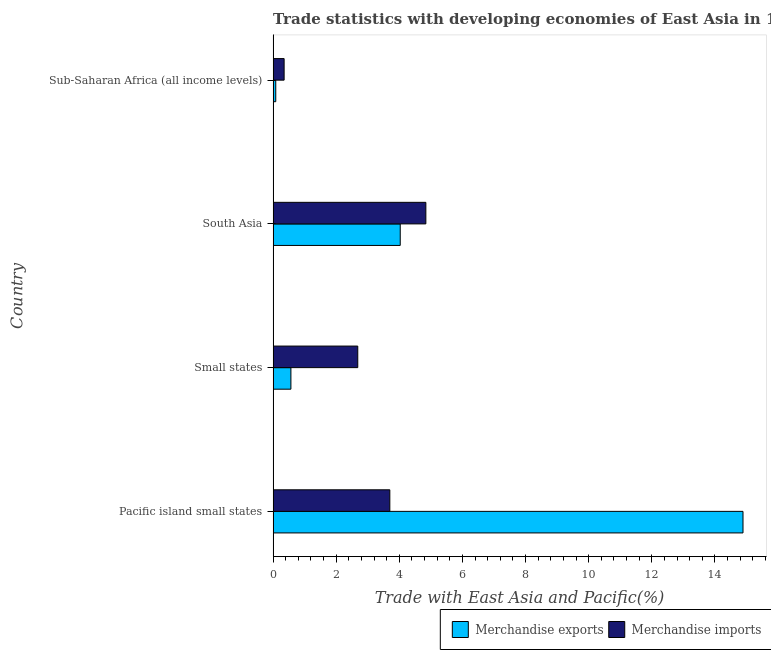How many groups of bars are there?
Ensure brevity in your answer.  4. Are the number of bars per tick equal to the number of legend labels?
Offer a very short reply. Yes. How many bars are there on the 3rd tick from the top?
Your answer should be very brief. 2. What is the label of the 3rd group of bars from the top?
Provide a succinct answer. Small states. What is the merchandise imports in Sub-Saharan Africa (all income levels)?
Offer a terse response. 0.35. Across all countries, what is the maximum merchandise exports?
Offer a very short reply. 14.89. Across all countries, what is the minimum merchandise imports?
Keep it short and to the point. 0.35. In which country was the merchandise imports maximum?
Provide a short and direct response. South Asia. In which country was the merchandise imports minimum?
Your answer should be very brief. Sub-Saharan Africa (all income levels). What is the total merchandise exports in the graph?
Provide a succinct answer. 19.56. What is the difference between the merchandise imports in Pacific island small states and that in Sub-Saharan Africa (all income levels)?
Your answer should be compact. 3.35. What is the difference between the merchandise imports in Pacific island small states and the merchandise exports in Sub-Saharan Africa (all income levels)?
Keep it short and to the point. 3.61. What is the average merchandise exports per country?
Give a very brief answer. 4.89. What is the difference between the merchandise exports and merchandise imports in Pacific island small states?
Offer a terse response. 11.19. In how many countries, is the merchandise exports greater than 2 %?
Give a very brief answer. 2. What is the ratio of the merchandise imports in Small states to that in Sub-Saharan Africa (all income levels)?
Provide a succinct answer. 7.69. Is the merchandise imports in Small states less than that in South Asia?
Your response must be concise. Yes. What is the difference between the highest and the second highest merchandise imports?
Offer a terse response. 1.14. What is the difference between the highest and the lowest merchandise imports?
Make the answer very short. 4.49. What does the 2nd bar from the bottom in Small states represents?
Your answer should be very brief. Merchandise imports. How many bars are there?
Your answer should be very brief. 8. How many countries are there in the graph?
Your answer should be very brief. 4. Are the values on the major ticks of X-axis written in scientific E-notation?
Make the answer very short. No. Where does the legend appear in the graph?
Your answer should be very brief. Bottom right. How many legend labels are there?
Give a very brief answer. 2. How are the legend labels stacked?
Provide a succinct answer. Horizontal. What is the title of the graph?
Your answer should be very brief. Trade statistics with developing economies of East Asia in 1982. What is the label or title of the X-axis?
Provide a succinct answer. Trade with East Asia and Pacific(%). What is the Trade with East Asia and Pacific(%) in Merchandise exports in Pacific island small states?
Provide a short and direct response. 14.89. What is the Trade with East Asia and Pacific(%) in Merchandise imports in Pacific island small states?
Keep it short and to the point. 3.7. What is the Trade with East Asia and Pacific(%) of Merchandise exports in Small states?
Offer a very short reply. 0.56. What is the Trade with East Asia and Pacific(%) in Merchandise imports in Small states?
Make the answer very short. 2.68. What is the Trade with East Asia and Pacific(%) in Merchandise exports in South Asia?
Make the answer very short. 4.03. What is the Trade with East Asia and Pacific(%) of Merchandise imports in South Asia?
Your answer should be compact. 4.84. What is the Trade with East Asia and Pacific(%) of Merchandise exports in Sub-Saharan Africa (all income levels)?
Offer a terse response. 0.08. What is the Trade with East Asia and Pacific(%) in Merchandise imports in Sub-Saharan Africa (all income levels)?
Provide a short and direct response. 0.35. Across all countries, what is the maximum Trade with East Asia and Pacific(%) in Merchandise exports?
Provide a succinct answer. 14.89. Across all countries, what is the maximum Trade with East Asia and Pacific(%) in Merchandise imports?
Your answer should be very brief. 4.84. Across all countries, what is the minimum Trade with East Asia and Pacific(%) in Merchandise exports?
Your response must be concise. 0.08. Across all countries, what is the minimum Trade with East Asia and Pacific(%) of Merchandise imports?
Offer a terse response. 0.35. What is the total Trade with East Asia and Pacific(%) of Merchandise exports in the graph?
Keep it short and to the point. 19.56. What is the total Trade with East Asia and Pacific(%) of Merchandise imports in the graph?
Your answer should be compact. 11.57. What is the difference between the Trade with East Asia and Pacific(%) in Merchandise exports in Pacific island small states and that in Small states?
Your answer should be very brief. 14.33. What is the difference between the Trade with East Asia and Pacific(%) of Merchandise imports in Pacific island small states and that in Small states?
Your answer should be very brief. 1.02. What is the difference between the Trade with East Asia and Pacific(%) of Merchandise exports in Pacific island small states and that in South Asia?
Offer a very short reply. 10.86. What is the difference between the Trade with East Asia and Pacific(%) of Merchandise imports in Pacific island small states and that in South Asia?
Make the answer very short. -1.14. What is the difference between the Trade with East Asia and Pacific(%) of Merchandise exports in Pacific island small states and that in Sub-Saharan Africa (all income levels)?
Your answer should be compact. 14.8. What is the difference between the Trade with East Asia and Pacific(%) of Merchandise imports in Pacific island small states and that in Sub-Saharan Africa (all income levels)?
Provide a short and direct response. 3.35. What is the difference between the Trade with East Asia and Pacific(%) of Merchandise exports in Small states and that in South Asia?
Your answer should be very brief. -3.46. What is the difference between the Trade with East Asia and Pacific(%) in Merchandise imports in Small states and that in South Asia?
Provide a succinct answer. -2.16. What is the difference between the Trade with East Asia and Pacific(%) in Merchandise exports in Small states and that in Sub-Saharan Africa (all income levels)?
Make the answer very short. 0.48. What is the difference between the Trade with East Asia and Pacific(%) in Merchandise imports in Small states and that in Sub-Saharan Africa (all income levels)?
Give a very brief answer. 2.33. What is the difference between the Trade with East Asia and Pacific(%) in Merchandise exports in South Asia and that in Sub-Saharan Africa (all income levels)?
Make the answer very short. 3.94. What is the difference between the Trade with East Asia and Pacific(%) in Merchandise imports in South Asia and that in Sub-Saharan Africa (all income levels)?
Offer a terse response. 4.49. What is the difference between the Trade with East Asia and Pacific(%) in Merchandise exports in Pacific island small states and the Trade with East Asia and Pacific(%) in Merchandise imports in Small states?
Make the answer very short. 12.21. What is the difference between the Trade with East Asia and Pacific(%) of Merchandise exports in Pacific island small states and the Trade with East Asia and Pacific(%) of Merchandise imports in South Asia?
Give a very brief answer. 10.05. What is the difference between the Trade with East Asia and Pacific(%) of Merchandise exports in Pacific island small states and the Trade with East Asia and Pacific(%) of Merchandise imports in Sub-Saharan Africa (all income levels)?
Give a very brief answer. 14.54. What is the difference between the Trade with East Asia and Pacific(%) of Merchandise exports in Small states and the Trade with East Asia and Pacific(%) of Merchandise imports in South Asia?
Make the answer very short. -4.28. What is the difference between the Trade with East Asia and Pacific(%) of Merchandise exports in Small states and the Trade with East Asia and Pacific(%) of Merchandise imports in Sub-Saharan Africa (all income levels)?
Give a very brief answer. 0.22. What is the difference between the Trade with East Asia and Pacific(%) in Merchandise exports in South Asia and the Trade with East Asia and Pacific(%) in Merchandise imports in Sub-Saharan Africa (all income levels)?
Make the answer very short. 3.68. What is the average Trade with East Asia and Pacific(%) in Merchandise exports per country?
Give a very brief answer. 4.89. What is the average Trade with East Asia and Pacific(%) of Merchandise imports per country?
Provide a short and direct response. 2.89. What is the difference between the Trade with East Asia and Pacific(%) of Merchandise exports and Trade with East Asia and Pacific(%) of Merchandise imports in Pacific island small states?
Your answer should be very brief. 11.19. What is the difference between the Trade with East Asia and Pacific(%) in Merchandise exports and Trade with East Asia and Pacific(%) in Merchandise imports in Small states?
Offer a terse response. -2.12. What is the difference between the Trade with East Asia and Pacific(%) in Merchandise exports and Trade with East Asia and Pacific(%) in Merchandise imports in South Asia?
Your response must be concise. -0.81. What is the difference between the Trade with East Asia and Pacific(%) of Merchandise exports and Trade with East Asia and Pacific(%) of Merchandise imports in Sub-Saharan Africa (all income levels)?
Your response must be concise. -0.26. What is the ratio of the Trade with East Asia and Pacific(%) in Merchandise exports in Pacific island small states to that in Small states?
Keep it short and to the point. 26.41. What is the ratio of the Trade with East Asia and Pacific(%) of Merchandise imports in Pacific island small states to that in Small states?
Provide a short and direct response. 1.38. What is the ratio of the Trade with East Asia and Pacific(%) of Merchandise exports in Pacific island small states to that in South Asia?
Your answer should be compact. 3.7. What is the ratio of the Trade with East Asia and Pacific(%) in Merchandise imports in Pacific island small states to that in South Asia?
Provide a succinct answer. 0.76. What is the ratio of the Trade with East Asia and Pacific(%) of Merchandise exports in Pacific island small states to that in Sub-Saharan Africa (all income levels)?
Keep it short and to the point. 177.59. What is the ratio of the Trade with East Asia and Pacific(%) of Merchandise imports in Pacific island small states to that in Sub-Saharan Africa (all income levels)?
Your response must be concise. 10.61. What is the ratio of the Trade with East Asia and Pacific(%) of Merchandise exports in Small states to that in South Asia?
Keep it short and to the point. 0.14. What is the ratio of the Trade with East Asia and Pacific(%) in Merchandise imports in Small states to that in South Asia?
Offer a very short reply. 0.55. What is the ratio of the Trade with East Asia and Pacific(%) of Merchandise exports in Small states to that in Sub-Saharan Africa (all income levels)?
Provide a short and direct response. 6.72. What is the ratio of the Trade with East Asia and Pacific(%) of Merchandise imports in Small states to that in Sub-Saharan Africa (all income levels)?
Ensure brevity in your answer.  7.69. What is the ratio of the Trade with East Asia and Pacific(%) of Merchandise exports in South Asia to that in Sub-Saharan Africa (all income levels)?
Give a very brief answer. 48.04. What is the ratio of the Trade with East Asia and Pacific(%) in Merchandise imports in South Asia to that in Sub-Saharan Africa (all income levels)?
Make the answer very short. 13.88. What is the difference between the highest and the second highest Trade with East Asia and Pacific(%) of Merchandise exports?
Offer a very short reply. 10.86. What is the difference between the highest and the second highest Trade with East Asia and Pacific(%) of Merchandise imports?
Ensure brevity in your answer.  1.14. What is the difference between the highest and the lowest Trade with East Asia and Pacific(%) of Merchandise exports?
Give a very brief answer. 14.8. What is the difference between the highest and the lowest Trade with East Asia and Pacific(%) in Merchandise imports?
Ensure brevity in your answer.  4.49. 